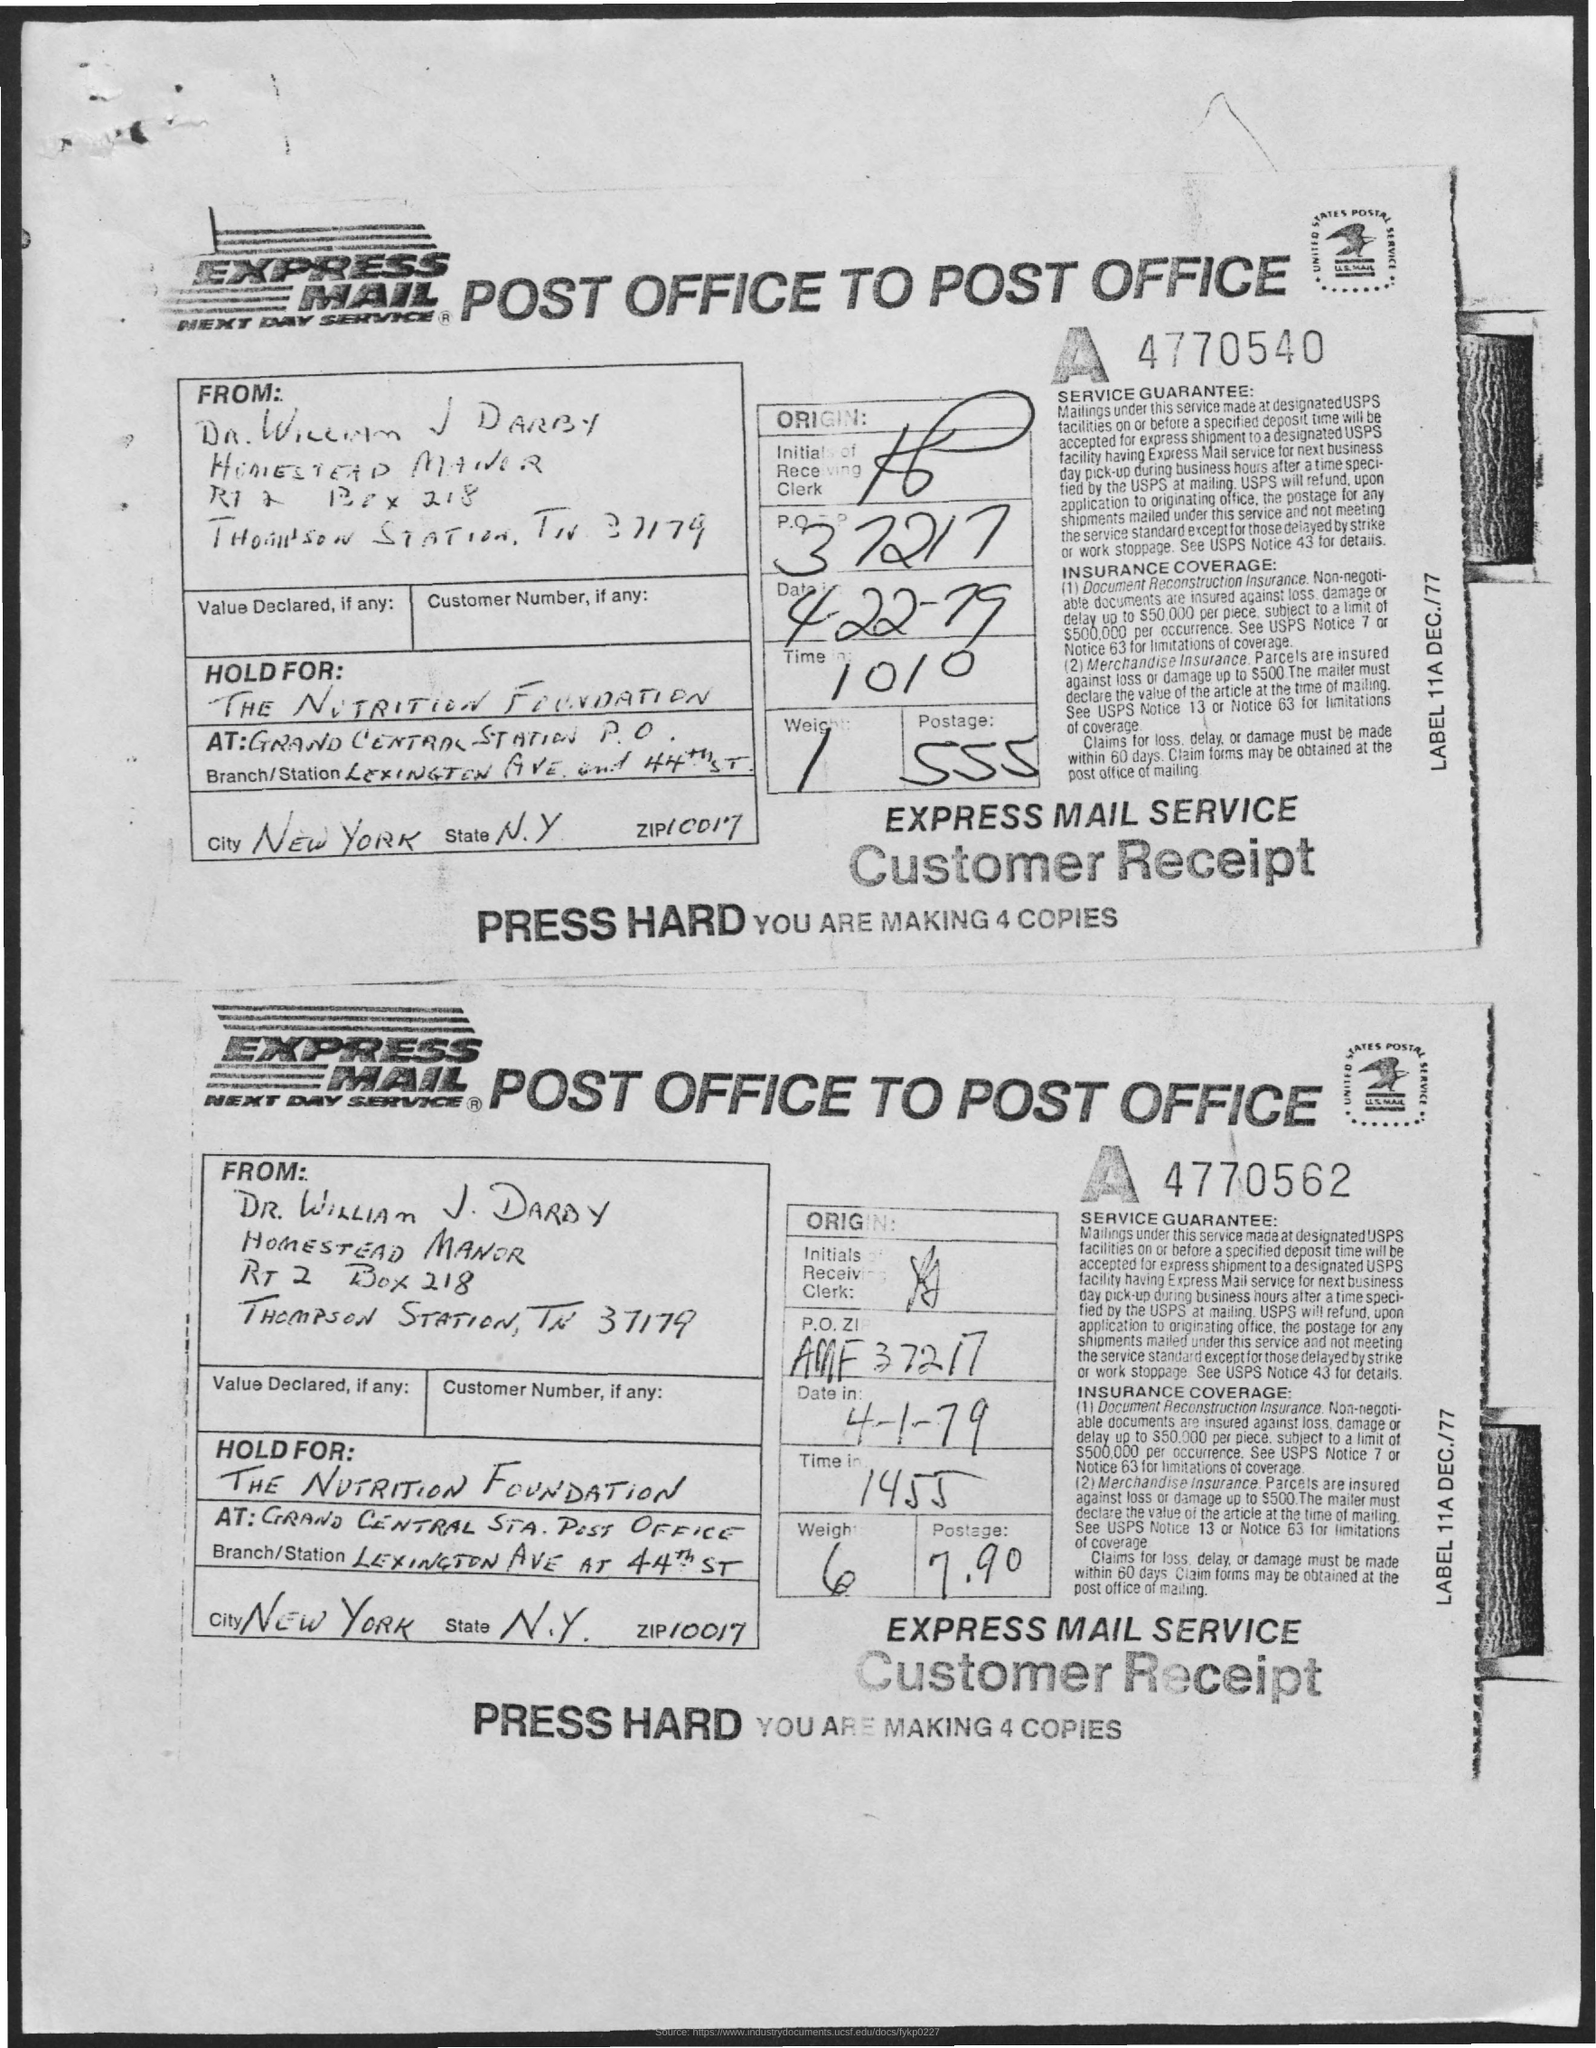Draw attention to some important aspects in this diagram. The state referred to as N.Y. is known by its full name. The name of the city is New York. The ZIP code is 10017. The PO Box number mentioned in the document is 218. 